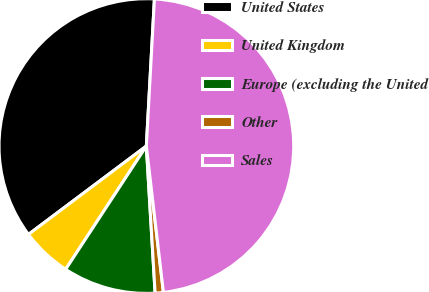Convert chart. <chart><loc_0><loc_0><loc_500><loc_500><pie_chart><fcel>United States<fcel>United Kingdom<fcel>Europe (excluding the United<fcel>Other<fcel>Sales<nl><fcel>36.11%<fcel>5.54%<fcel>10.17%<fcel>0.9%<fcel>47.28%<nl></chart> 